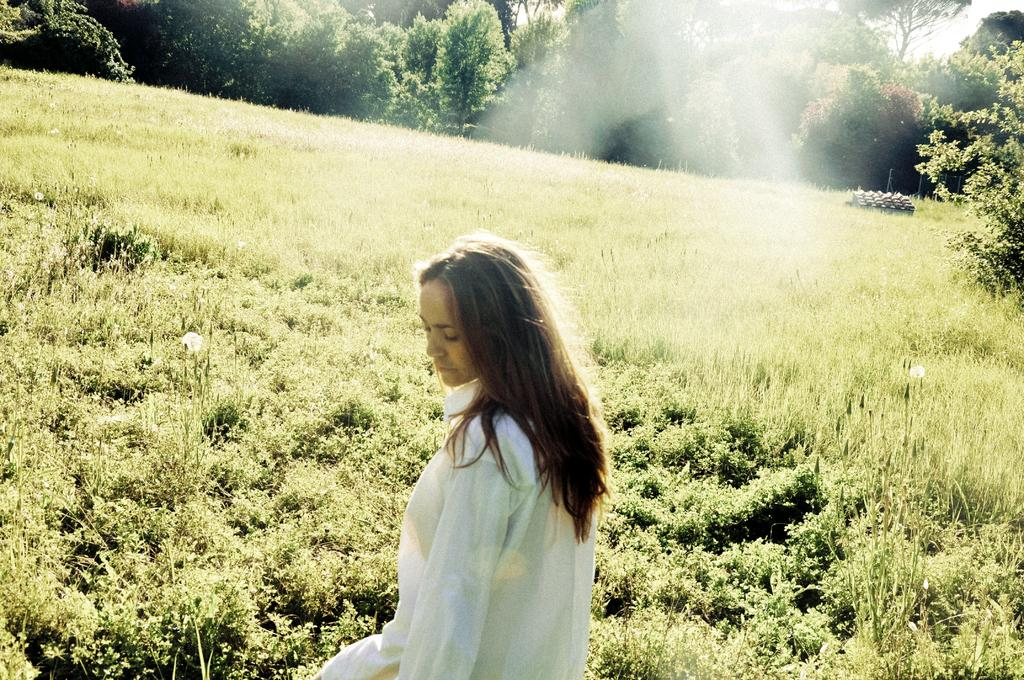What type of vegetation can be seen in the image? There is grass, plants, and trees in the image. Can you describe the natural environment in the image? The natural environment includes grass, plants, and trees. What else is visible in the image besides vegetation? There is smoke visible in the image. Who is present in the image? There is a woman wearing a white dress in the image. What type of agreement is being discussed in the image? There is no discussion or agreement present in the image. 